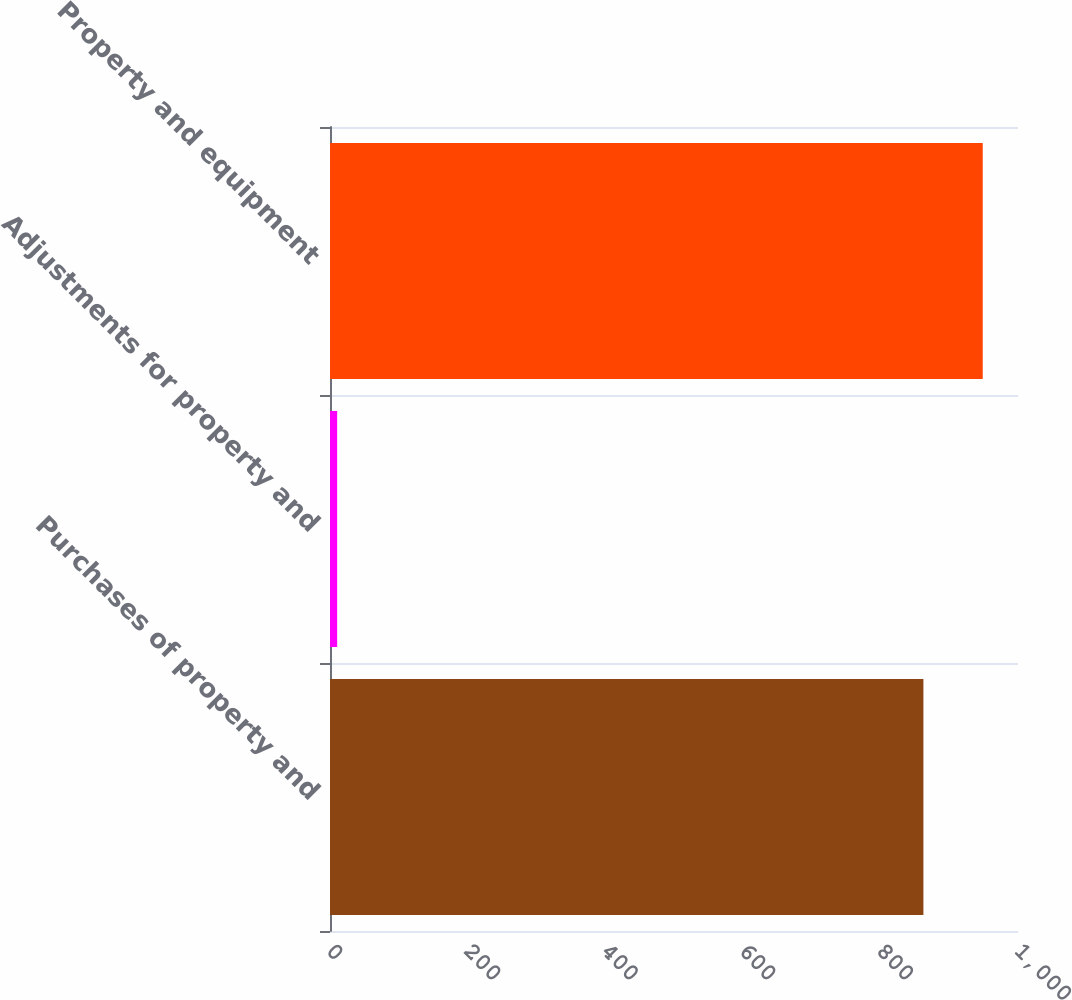Convert chart to OTSL. <chart><loc_0><loc_0><loc_500><loc_500><bar_chart><fcel>Purchases of property and<fcel>Adjustments for property and<fcel>Property and equipment<nl><fcel>862.5<fcel>10.4<fcel>948.75<nl></chart> 